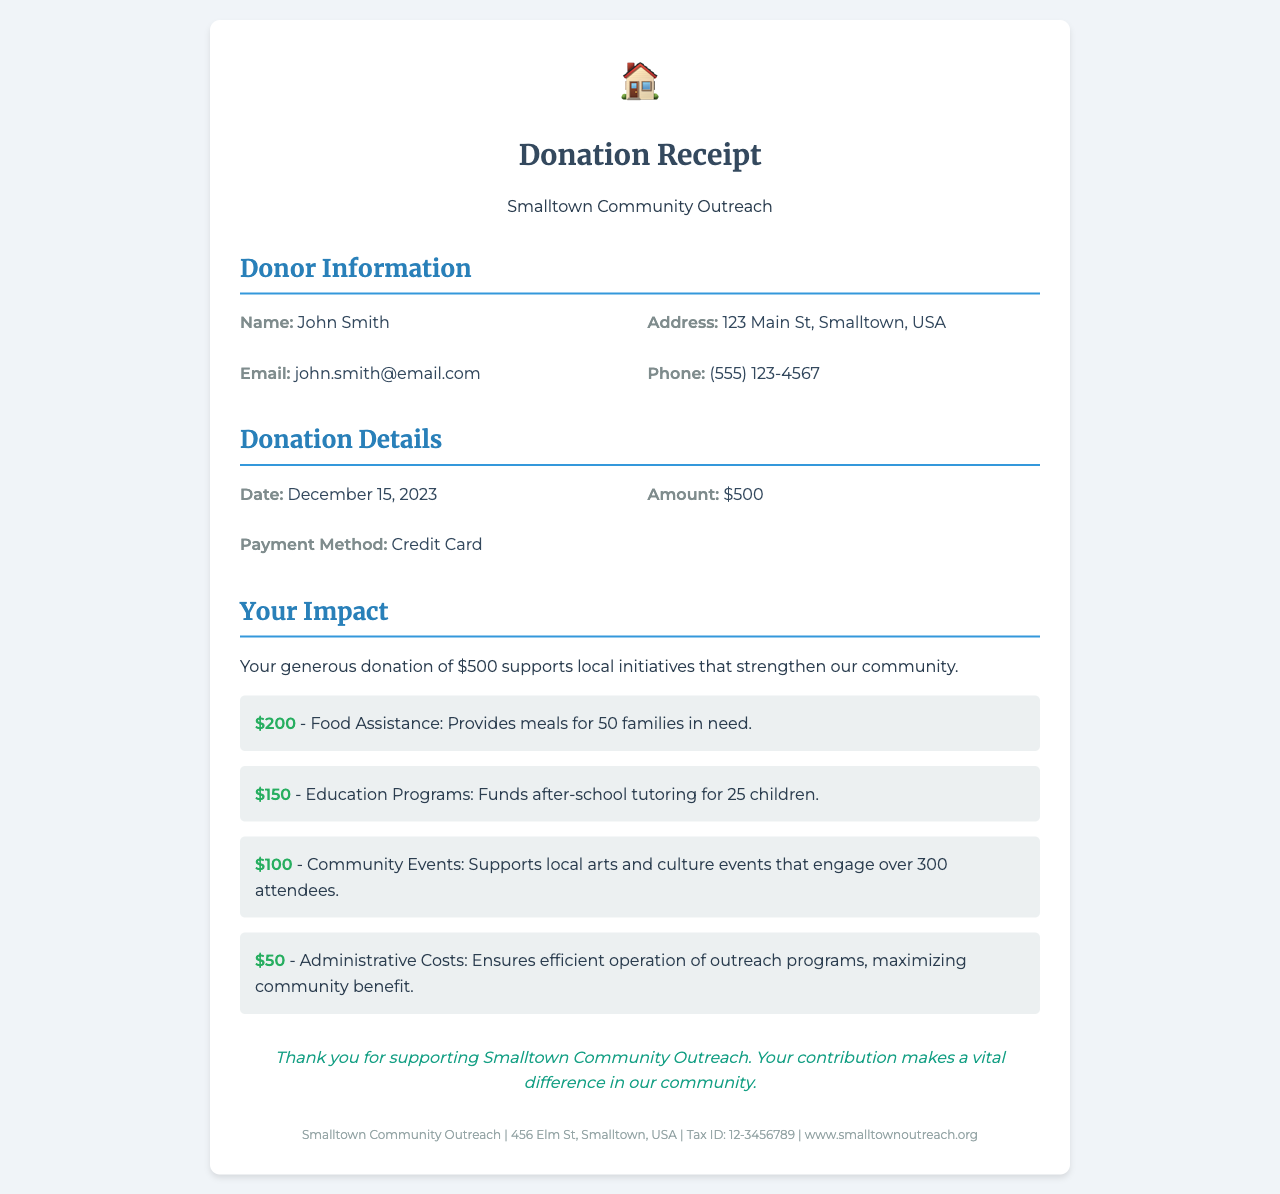What is the name of the donor? The document states the donor's name under "Donor Information," which is John Smith.
Answer: John Smith What is the amount donated? The donation amount is specified in the "Donation Details" section, which shows $500.
Answer: $500 What date was the donation made? The donation date is provided in the "Donation Details" section, listed as December 15, 2023.
Answer: December 15, 2023 How many families benefited from the Food Assistance program? The impact of the Food Assistance program indicates it provides meals for 50 families in need.
Answer: 50 families What is the total amount allocated for Community Events? The document breaks down the donation impacts, showing that $100 is allocated for Community Events.
Answer: $100 What is the payment method used for the donation? The payment method is mentioned in the "Donation Details" as Credit Card.
Answer: Credit Card Which program received the most funding? The program with the largest funding is Food Assistance, receiving $200.
Answer: Food Assistance How many children benefit from the Education Programs? According to the impact section, 25 children benefit from the Education Programs funded by the donation.
Answer: 25 children What percentage of the total donation goes to Administrative Costs? The Administrative Costs receive $50, which is 10% of the total donation of $500.
Answer: 10% 